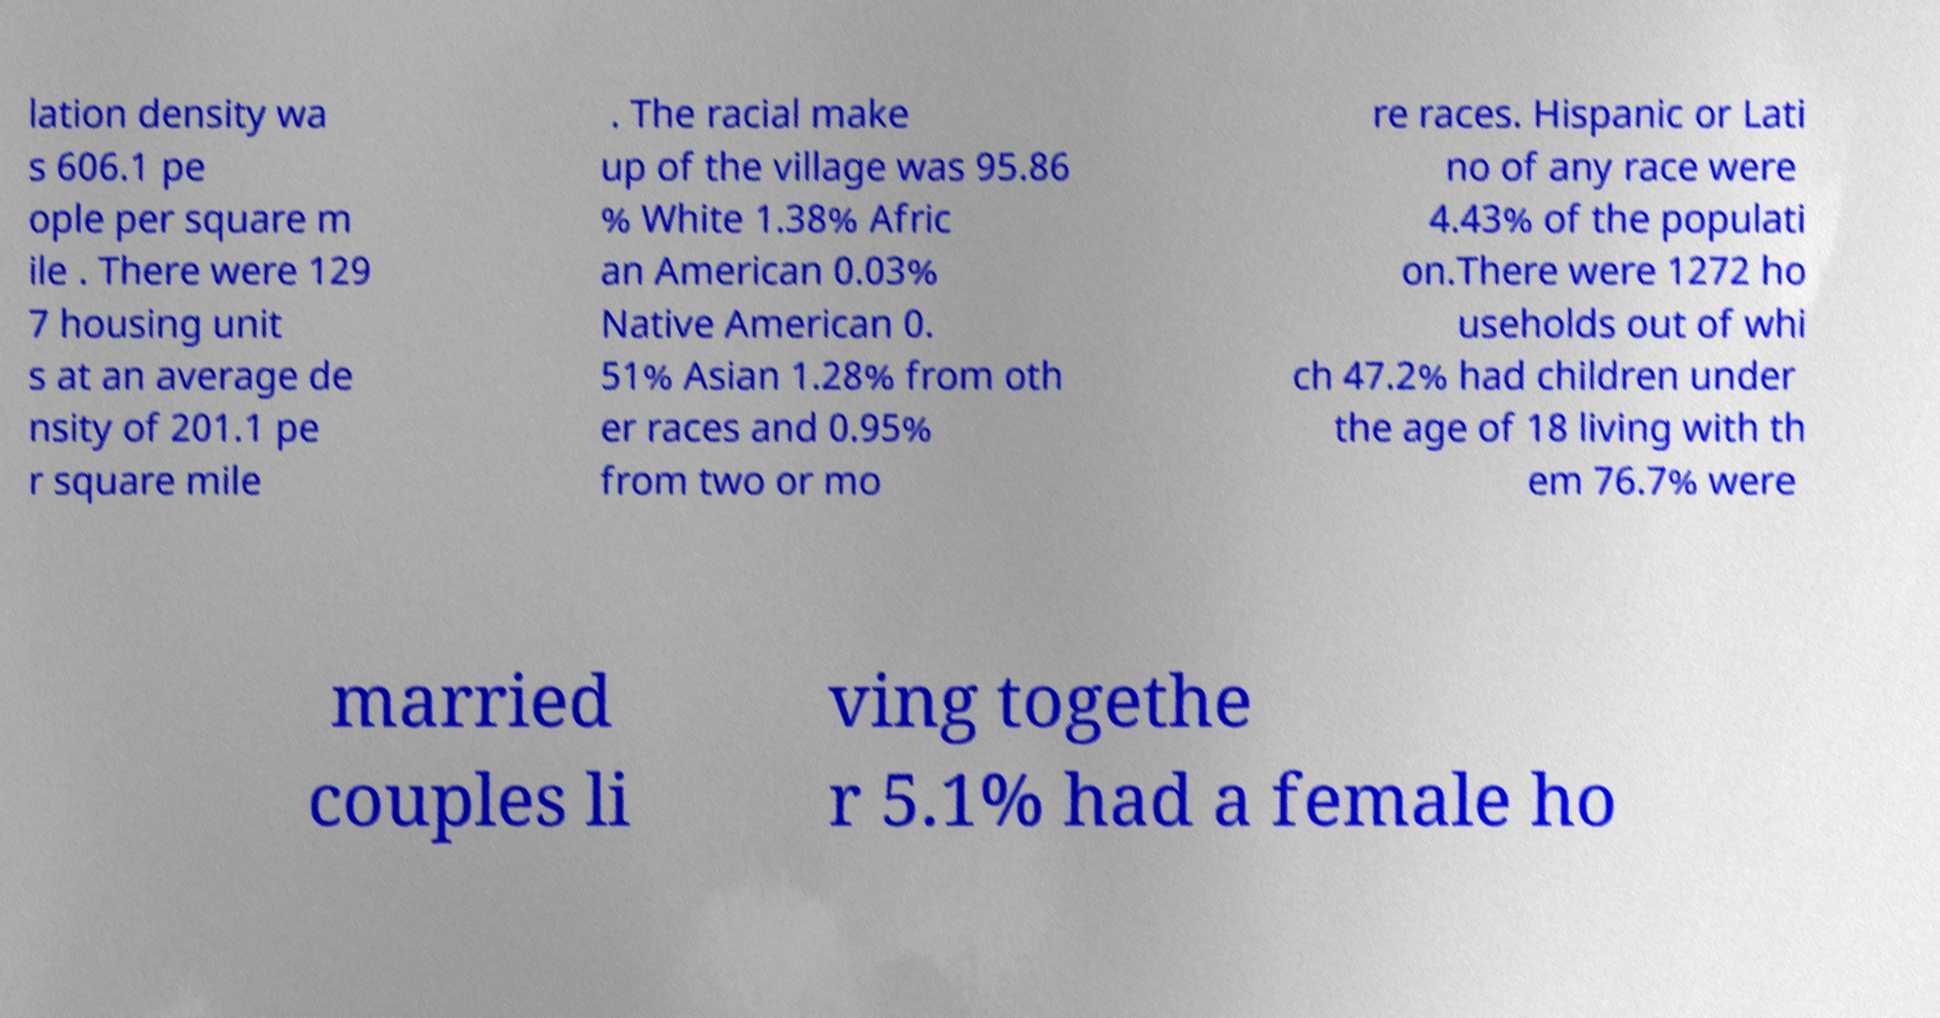Can you read and provide the text displayed in the image?This photo seems to have some interesting text. Can you extract and type it out for me? lation density wa s 606.1 pe ople per square m ile . There were 129 7 housing unit s at an average de nsity of 201.1 pe r square mile . The racial make up of the village was 95.86 % White 1.38% Afric an American 0.03% Native American 0. 51% Asian 1.28% from oth er races and 0.95% from two or mo re races. Hispanic or Lati no of any race were 4.43% of the populati on.There were 1272 ho useholds out of whi ch 47.2% had children under the age of 18 living with th em 76.7% were married couples li ving togethe r 5.1% had a female ho 